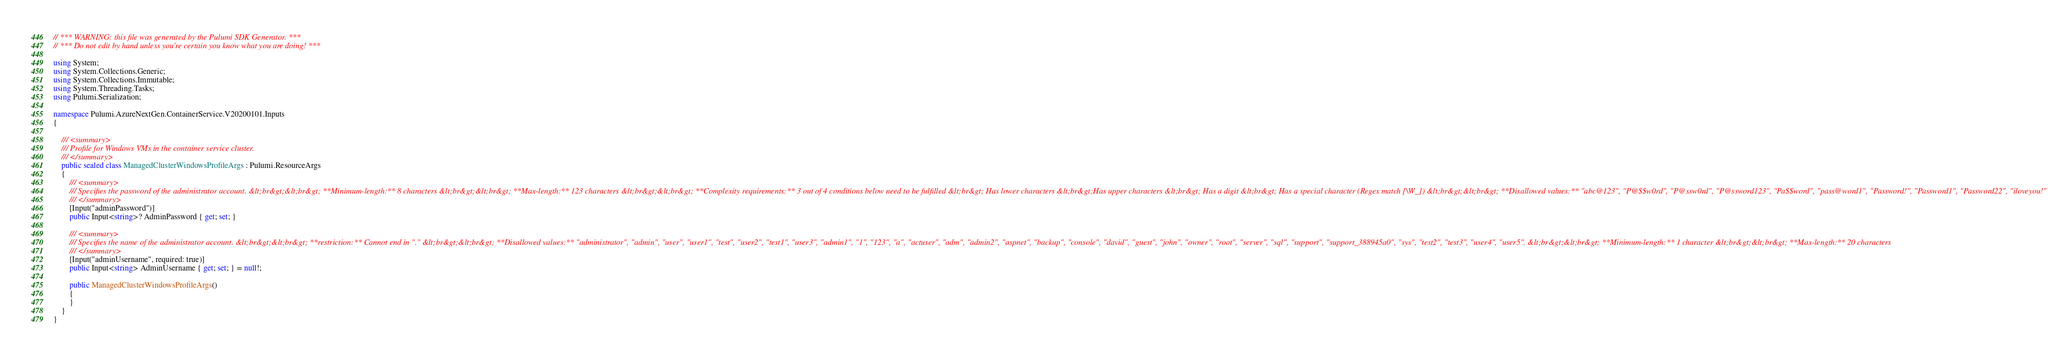Convert code to text. <code><loc_0><loc_0><loc_500><loc_500><_C#_>// *** WARNING: this file was generated by the Pulumi SDK Generator. ***
// *** Do not edit by hand unless you're certain you know what you are doing! ***

using System;
using System.Collections.Generic;
using System.Collections.Immutable;
using System.Threading.Tasks;
using Pulumi.Serialization;

namespace Pulumi.AzureNextGen.ContainerService.V20200101.Inputs
{

    /// <summary>
    /// Profile for Windows VMs in the container service cluster.
    /// </summary>
    public sealed class ManagedClusterWindowsProfileArgs : Pulumi.ResourceArgs
    {
        /// <summary>
        /// Specifies the password of the administrator account. &lt;br&gt;&lt;br&gt; **Minimum-length:** 8 characters &lt;br&gt;&lt;br&gt; **Max-length:** 123 characters &lt;br&gt;&lt;br&gt; **Complexity requirements:** 3 out of 4 conditions below need to be fulfilled &lt;br&gt; Has lower characters &lt;br&gt;Has upper characters &lt;br&gt; Has a digit &lt;br&gt; Has a special character (Regex match [\W_]) &lt;br&gt;&lt;br&gt; **Disallowed values:** "abc@123", "P@$$w0rd", "P@ssw0rd", "P@ssword123", "Pa$$word", "pass@word1", "Password!", "Password1", "Password22", "iloveyou!"
        /// </summary>
        [Input("adminPassword")]
        public Input<string>? AdminPassword { get; set; }

        /// <summary>
        /// Specifies the name of the administrator account. &lt;br&gt;&lt;br&gt; **restriction:** Cannot end in "." &lt;br&gt;&lt;br&gt; **Disallowed values:** "administrator", "admin", "user", "user1", "test", "user2", "test1", "user3", "admin1", "1", "123", "a", "actuser", "adm", "admin2", "aspnet", "backup", "console", "david", "guest", "john", "owner", "root", "server", "sql", "support", "support_388945a0", "sys", "test2", "test3", "user4", "user5". &lt;br&gt;&lt;br&gt; **Minimum-length:** 1 character &lt;br&gt;&lt;br&gt; **Max-length:** 20 characters
        /// </summary>
        [Input("adminUsername", required: true)]
        public Input<string> AdminUsername { get; set; } = null!;

        public ManagedClusterWindowsProfileArgs()
        {
        }
    }
}
</code> 